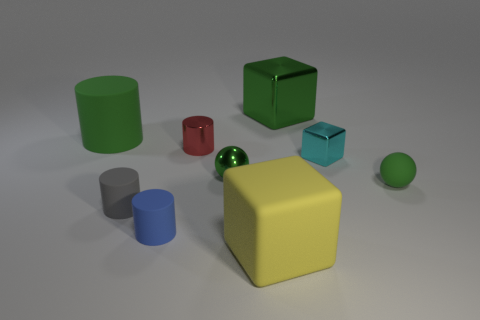The big metal block is what color?
Provide a short and direct response. Green. There is a metallic cube that is in front of the green rubber object that is left of the shiny object that is behind the red thing; what is its size?
Your answer should be compact. Small. What number of other objects are the same size as the yellow thing?
Your response must be concise. 2. How many large green things have the same material as the cyan block?
Ensure brevity in your answer.  1. What is the shape of the large green object that is left of the red metallic thing?
Your response must be concise. Cylinder. Does the gray cylinder have the same material as the big cube that is in front of the tiny blue object?
Your response must be concise. Yes. Is there a tiny matte object?
Your response must be concise. Yes. There is a big rubber object behind the sphere that is to the right of the big shiny cube; is there a green object behind it?
Ensure brevity in your answer.  Yes. What number of tiny things are either yellow things or green spheres?
Make the answer very short. 2. What color is the rubber cylinder that is the same size as the blue thing?
Offer a terse response. Gray. 